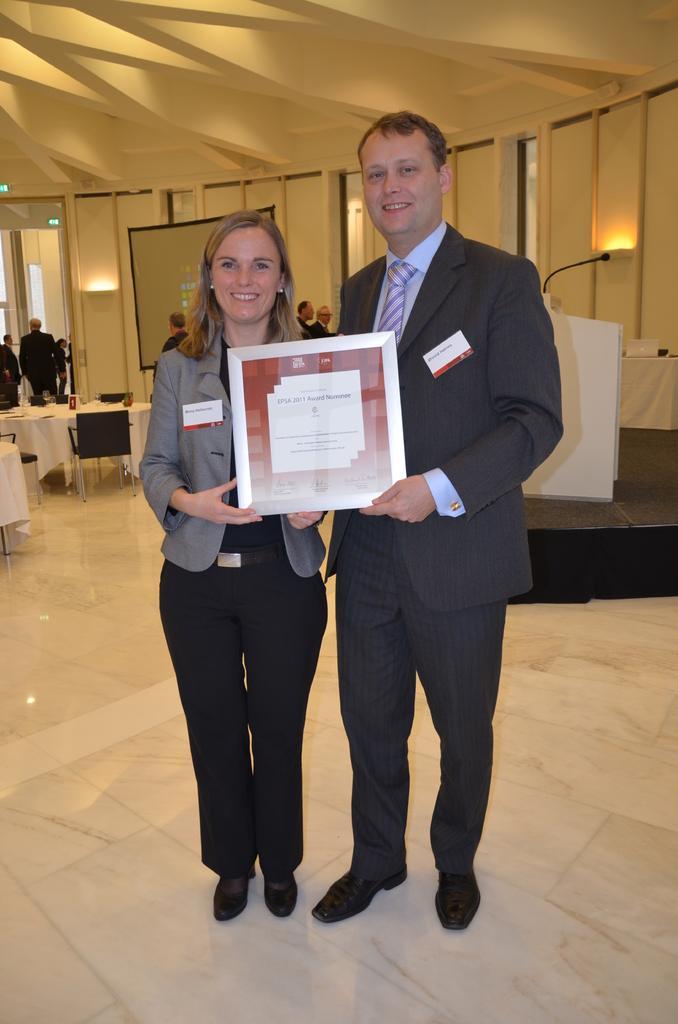Describe this image in one or two sentences. In this image we can see many people. There are two persons are holding an object. There is a podium and a microphone in the image. There are few tables and chairs in the image. There are many objects placed on the tables. There is a projector screen in the image. There are few lamps in the image. 